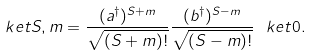Convert formula to latex. <formula><loc_0><loc_0><loc_500><loc_500>\ k e t { S , m } = \frac { ( a ^ { \dag } ) ^ { S + m } } { \sqrt { ( S + m ) ! } } \frac { ( b ^ { \dag } ) ^ { S - m } } { \sqrt { ( S - m ) ! } } \ k e t { 0 } .</formula> 